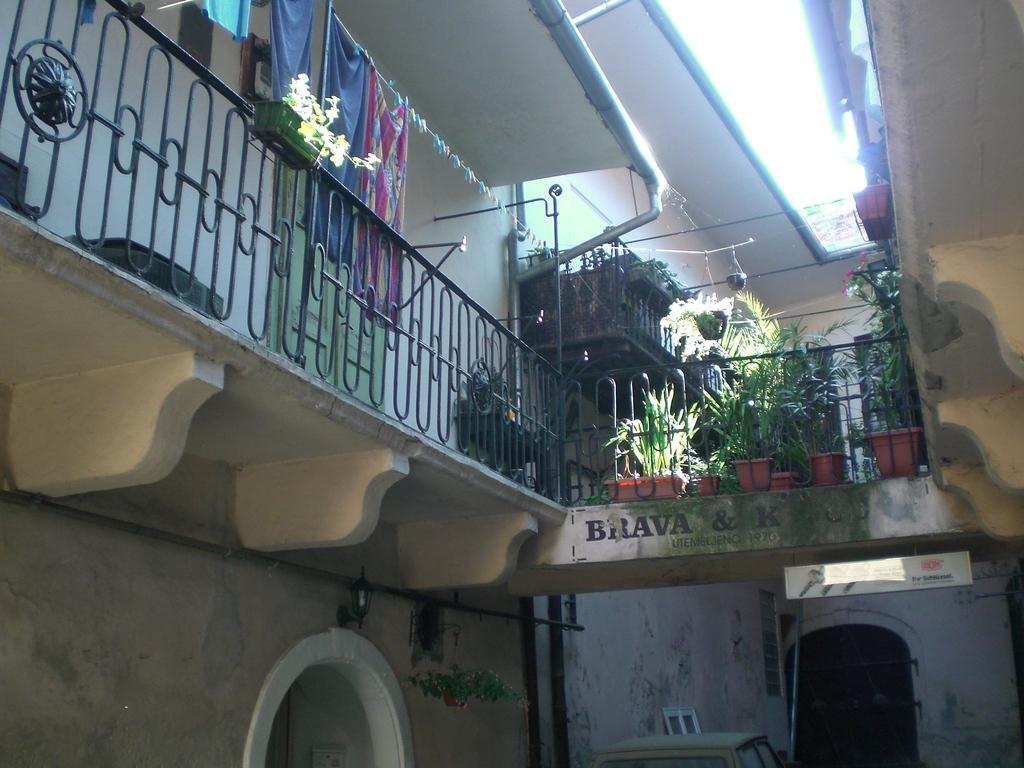How would you summarize this image in a sentence or two? In this picture we can see a building,fence,house plants and clothes. 